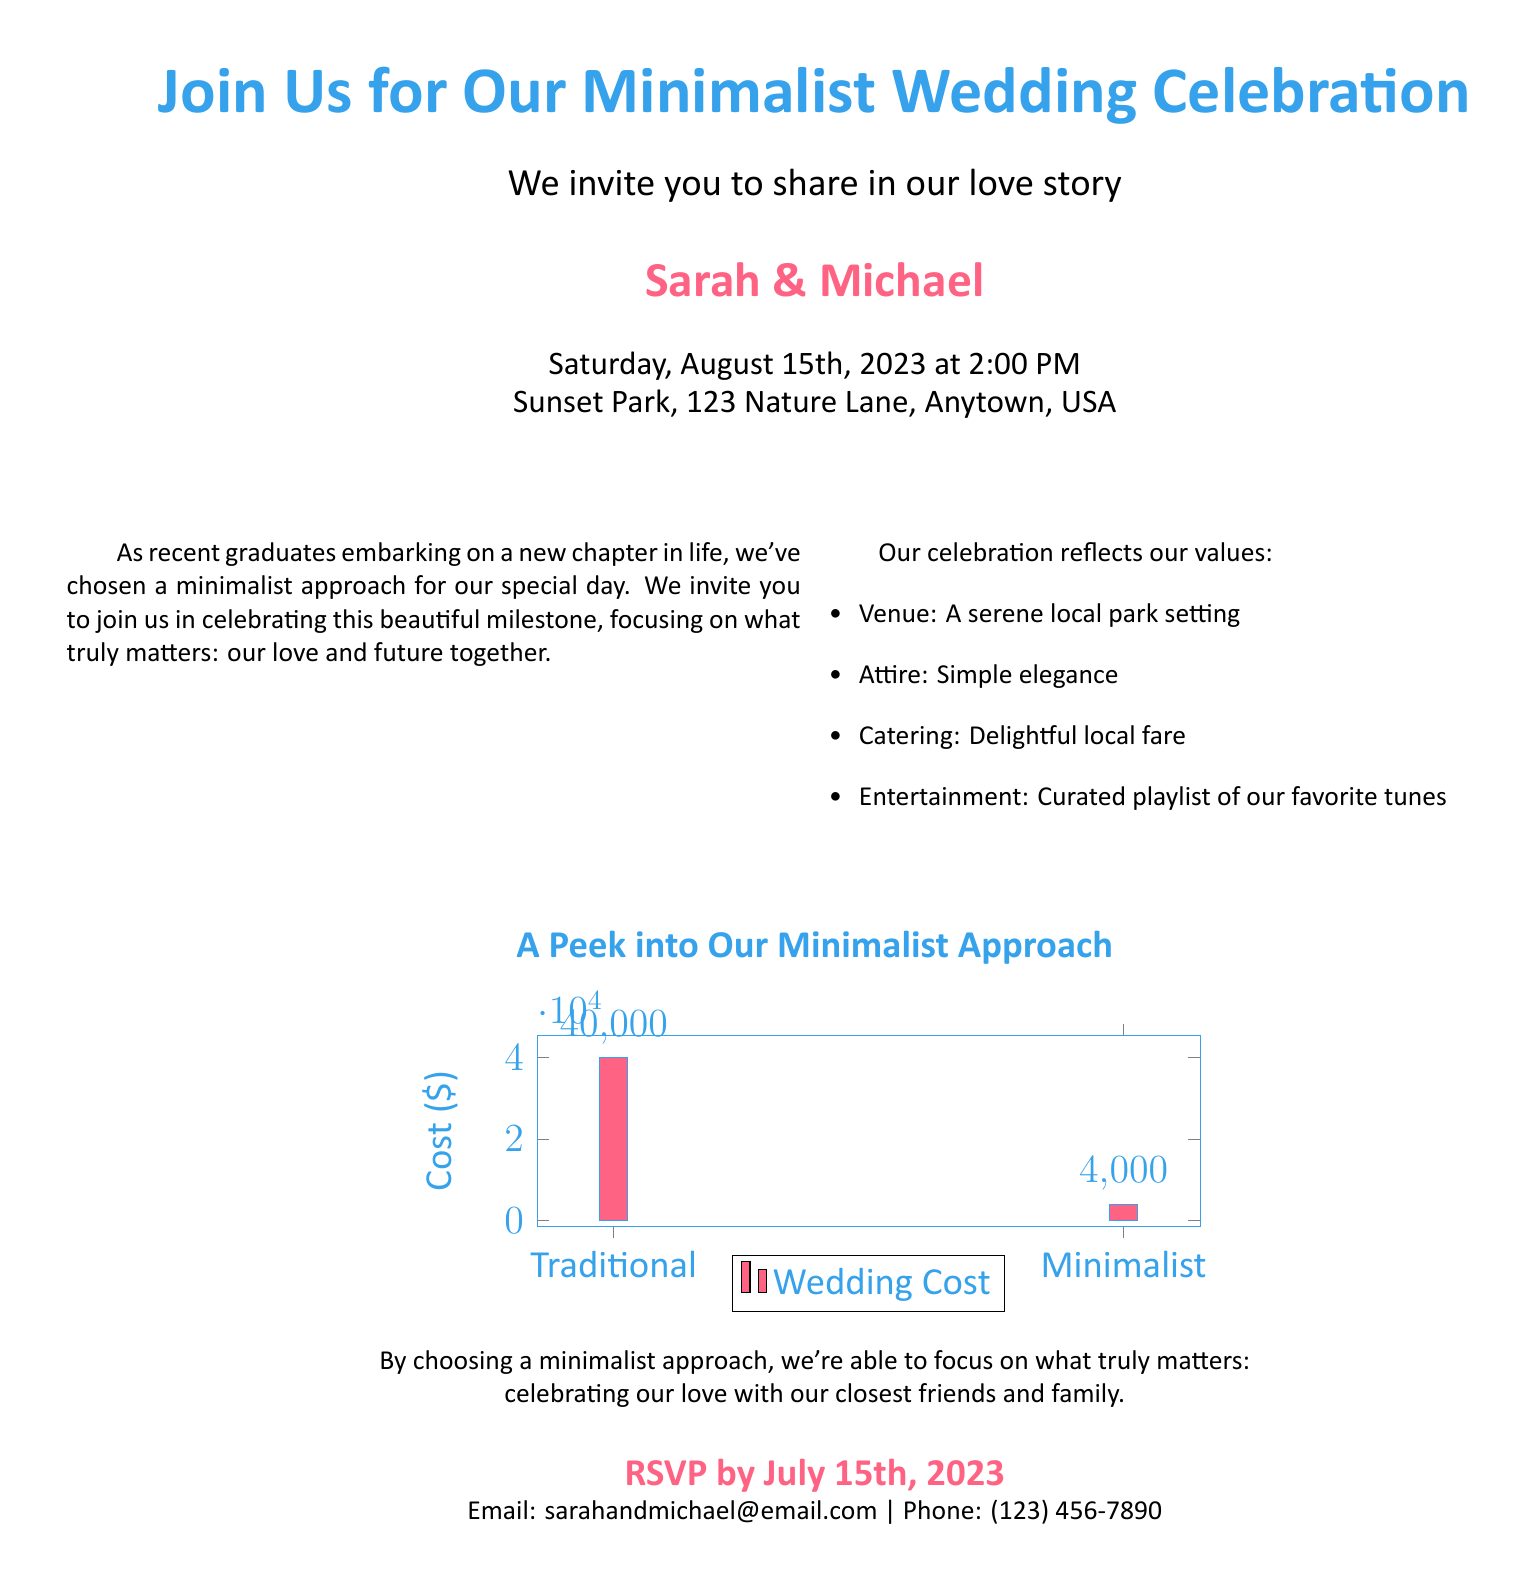What date is the wedding scheduled for? The wedding date is explicitly stated in the invitation section.
Answer: August 15th, 2023 What venue will the wedding take place at? The venue location is provided within the details of the invitation.
Answer: Sunset Park What is the estimated cost for a traditional wedding? The cost breakdown shows the estimated cost for a traditional wedding in the infographic.
Answer: 40000 What is the estimated cost for a minimalist wedding? The infographic provides the estimated cost for a minimalist wedding.
Answer: 4000 Who are the couple getting married? The names of the couple are highlighted prominently in the invitation.
Answer: Sarah & Michael What is the theme of the wedding? The theme is emphasized in the introduction and throughout the document.
Answer: Minimalist What is the RSVP deadline? The RSVP date is mentioned towards the end of the document.
Answer: July 15th, 2023 What kind of entertainment is planned for the wedding? The type of entertainment is listed among the values of the celebration.
Answer: Curated playlist What attire is requested for guests? The attire expectation is mentioned in the details of the wedding values.
Answer: Simple elegance 